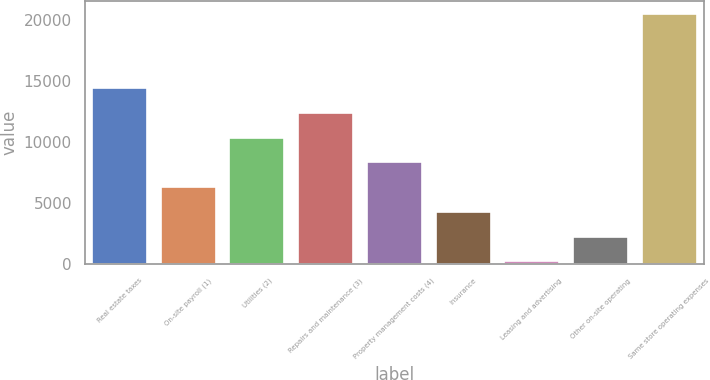Convert chart to OTSL. <chart><loc_0><loc_0><loc_500><loc_500><bar_chart><fcel>Real estate taxes<fcel>On-site payroll (1)<fcel>Utilities (2)<fcel>Repairs and maintenance (3)<fcel>Property management costs (4)<fcel>Insurance<fcel>Leasing and advertising<fcel>Other on-site operating<fcel>Same store operating expenses<nl><fcel>14450.6<fcel>6327.4<fcel>10389<fcel>12419.8<fcel>8358.2<fcel>4296.6<fcel>235<fcel>2265.8<fcel>20543<nl></chart> 